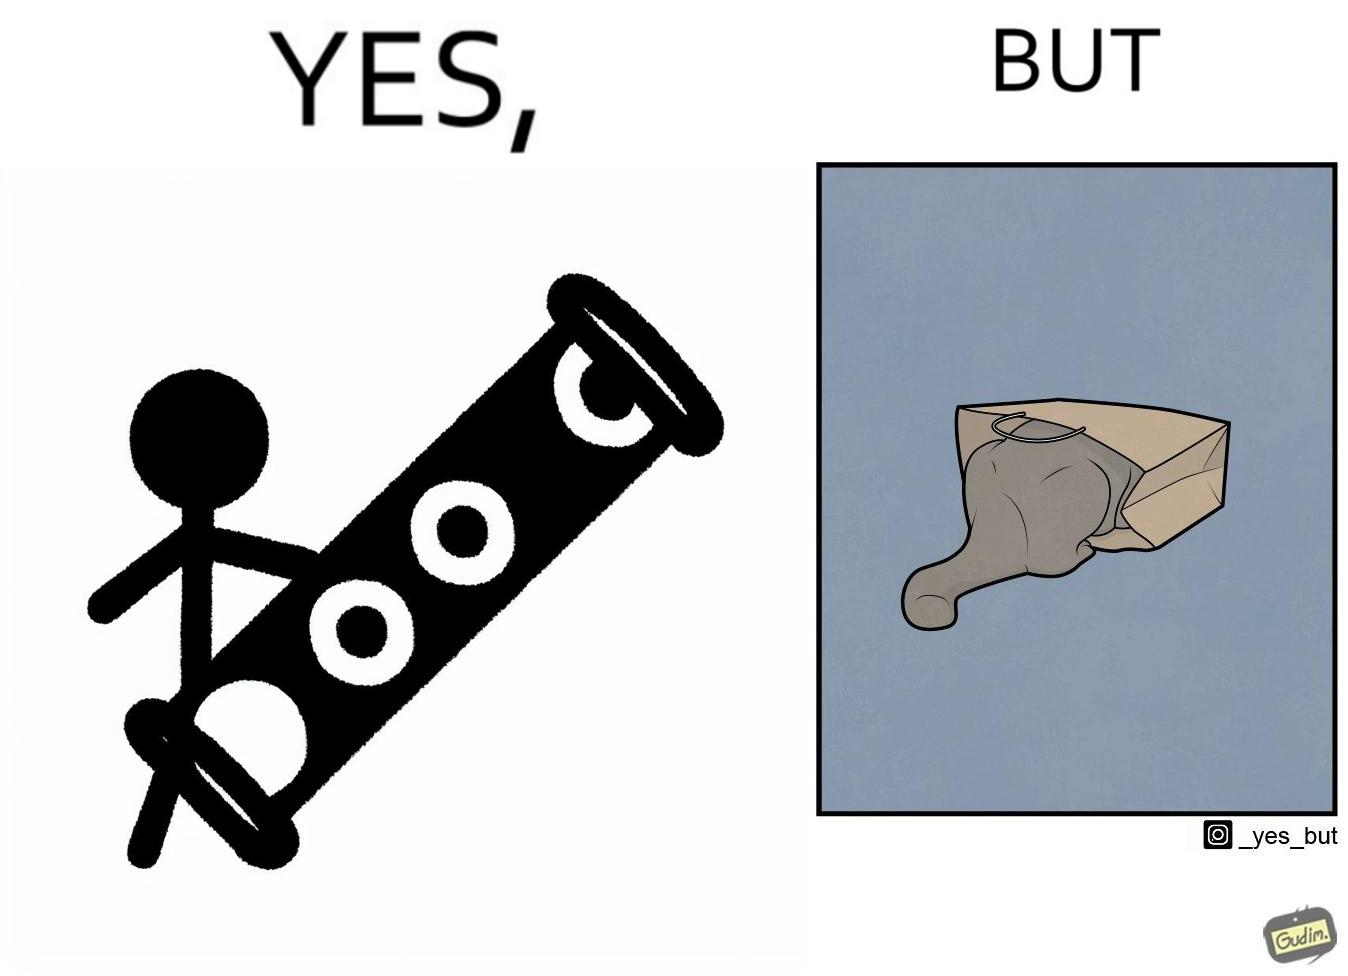What is shown in this image? The image is funny, because even when there is a dedicated thing for the animal to play with it still is hiding itself in the paper bag 